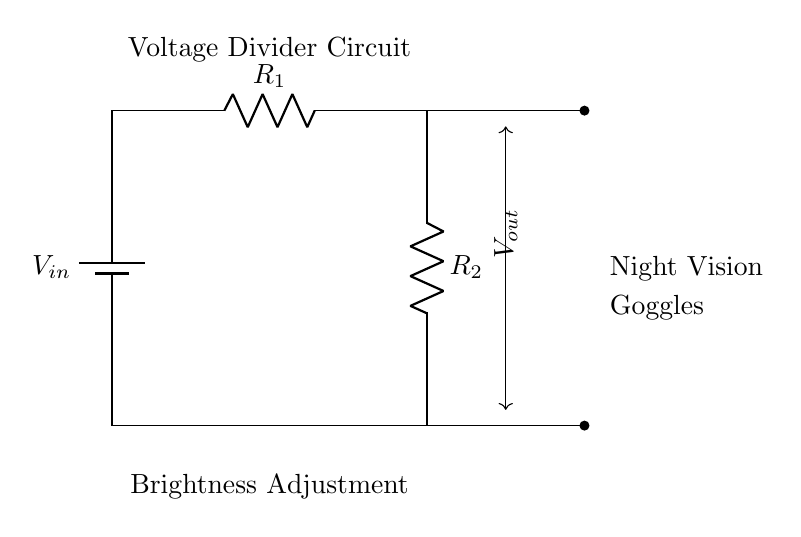What does the circuit do? The voltage divider circuit adjusts the brightness of the night vision goggles by dividing the input voltage into an output voltage that influences the device's overall brightness.
Answer: Adjusts brightness What are the components used in the circuit? The circuit consists of a battery and two resistors, labeled R1 and R2. These components work together to create the voltage divider necessary for adjusting brightness.
Answer: Battery and two resistors What is the voltage in the circuit denoted as? The voltage provided to the circuit from the battery is labeled V in, indicating the input voltage for the divider.
Answer: V in What does the output voltage control in the circuit? The output voltage, denoted as V out, controls the brightness level of the night vision goggles by varying the voltage supplied to them.
Answer: Brightness adjustment How is the output voltage derived in a voltage divider? The output voltage in a voltage divider is determined by the formula V out = V in * (R2 / (R1 + R2)), where V in is the input voltage and R1 and R2 are the resistances. This relationship explains how the resistors share the voltage based on their values.
Answer: Voltage division formula What happens when R1 is increased in value? When R1 is increased, the ratio of R1 to the total resistance (R1 + R2) increases, leading to a decrease in the output voltage V out. This results in a lower brightness level for the night vision goggles.
Answer: Decrease in output voltage What does the arrow indicate in the diagram? The arrows indicate the direction of the current flow and highlight the voltage levels at specific points in the circuit, showing how the resistors relate to V out.
Answer: Direction of current flow 